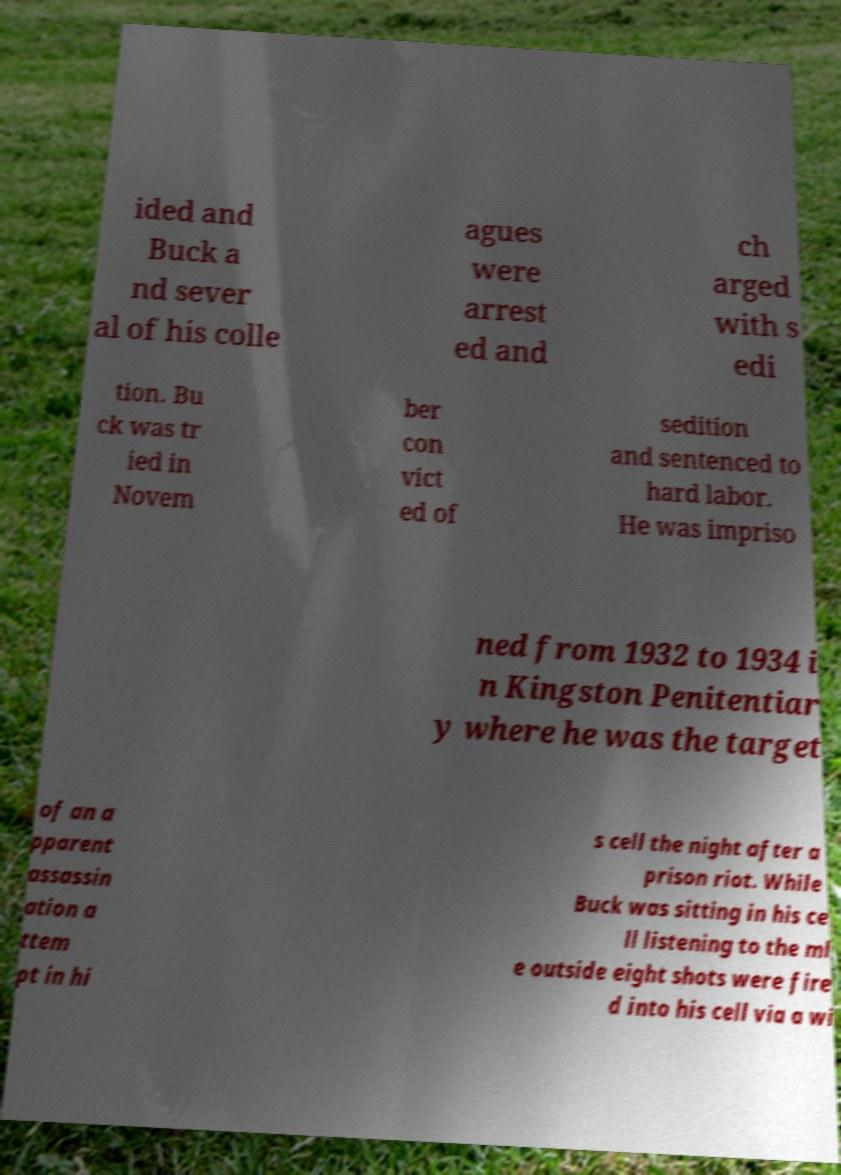Could you assist in decoding the text presented in this image and type it out clearly? ided and Buck a nd sever al of his colle agues were arrest ed and ch arged with s edi tion. Bu ck was tr ied in Novem ber con vict ed of sedition and sentenced to hard labor. He was impriso ned from 1932 to 1934 i n Kingston Penitentiar y where he was the target of an a pparent assassin ation a ttem pt in hi s cell the night after a prison riot. While Buck was sitting in his ce ll listening to the ml e outside eight shots were fire d into his cell via a wi 